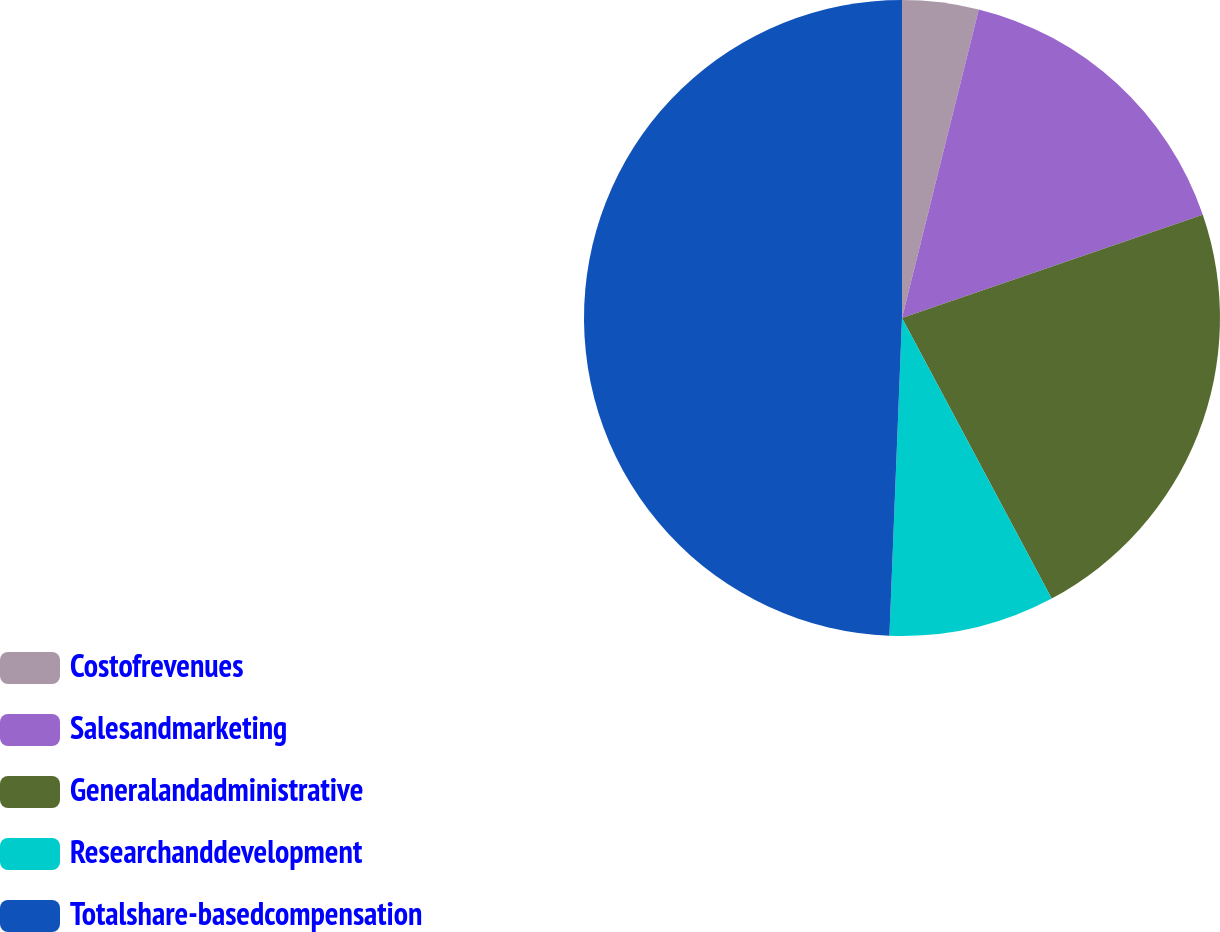Convert chart to OTSL. <chart><loc_0><loc_0><loc_500><loc_500><pie_chart><fcel>Costofrevenues<fcel>Salesandmarketing<fcel>Generalandadministrative<fcel>Researchanddevelopment<fcel>Totalshare-basedcompensation<nl><fcel>3.88%<fcel>15.86%<fcel>22.46%<fcel>8.43%<fcel>49.37%<nl></chart> 